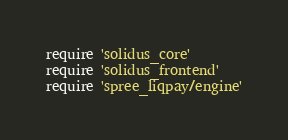<code> <loc_0><loc_0><loc_500><loc_500><_Ruby_>require 'solidus_core'
require 'solidus_frontend'
require 'spree_liqpay/engine'
</code> 